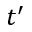Convert formula to latex. <formula><loc_0><loc_0><loc_500><loc_500>t ^ { \prime }</formula> 